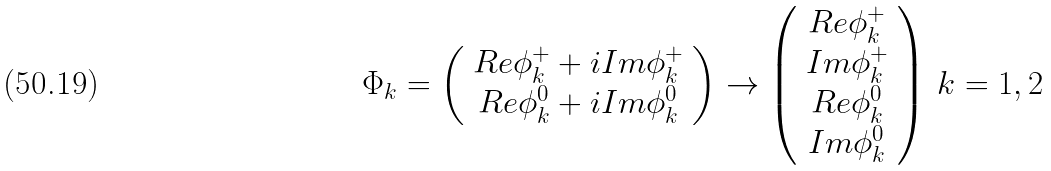Convert formula to latex. <formula><loc_0><loc_0><loc_500><loc_500>\Phi _ { k } = \left ( \begin{array} { c } R e \phi _ { k } ^ { + } + i I m \phi _ { k } ^ { + } \\ R e \phi _ { k } ^ { 0 } + i I m \phi _ { k } ^ { 0 } \end{array} \right ) \rightarrow \left ( \begin{array} { c } R e \phi _ { k } ^ { + } \\ I m \phi _ { k } ^ { + } \\ R e \phi _ { k } ^ { 0 } \\ I m \phi _ { k } ^ { 0 } \end{array} \right ) \, k = 1 , 2 \,</formula> 